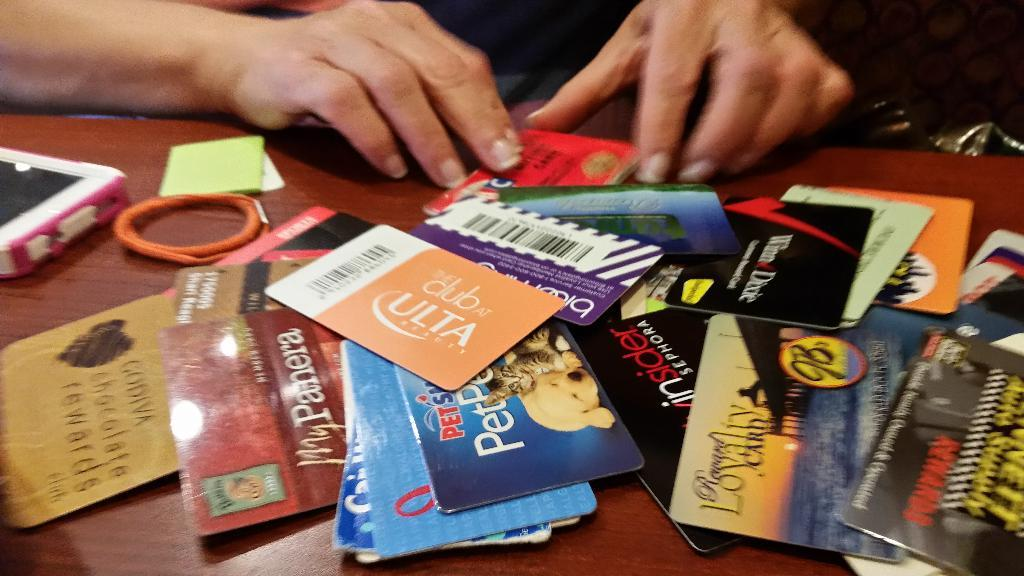<image>
Share a concise interpretation of the image provided. Loyalty cards for various stores and restaurants are on a table, including ones for PetSmart and Ulta. 